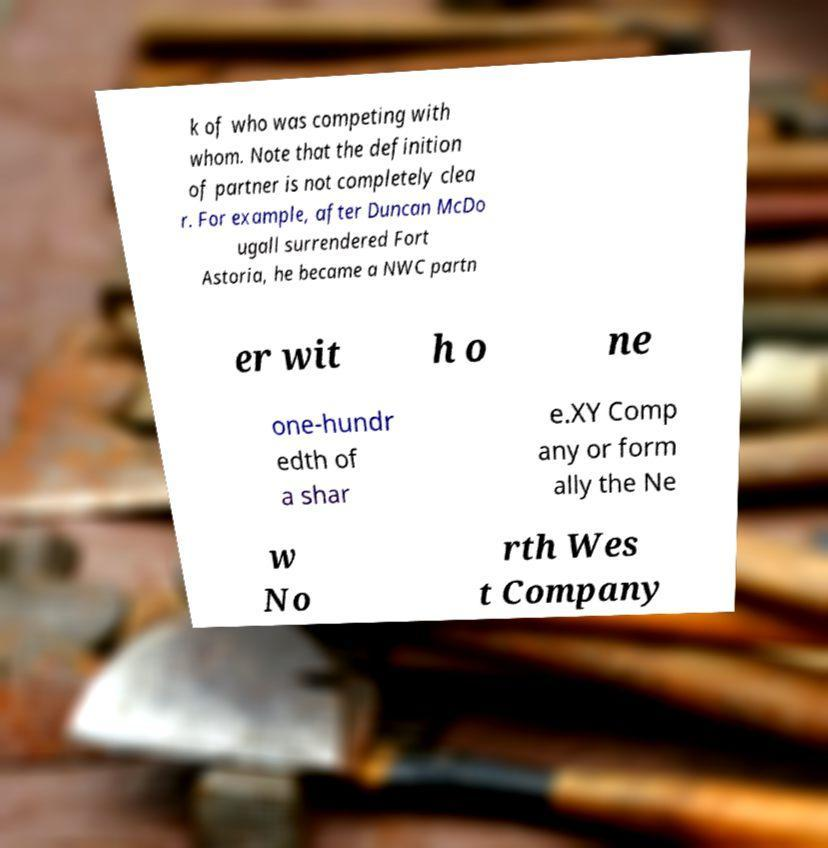What messages or text are displayed in this image? I need them in a readable, typed format. k of who was competing with whom. Note that the definition of partner is not completely clea r. For example, after Duncan McDo ugall surrendered Fort Astoria, he became a NWC partn er wit h o ne one-hundr edth of a shar e.XY Comp any or form ally the Ne w No rth Wes t Company 